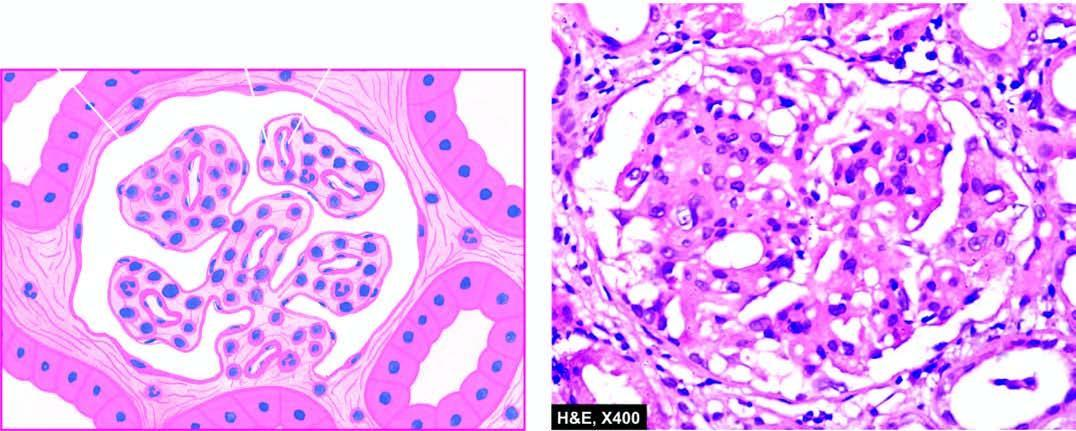s there increase in the mesangial matrix between the capillaries?
Answer the question using a single word or phrase. Yes 